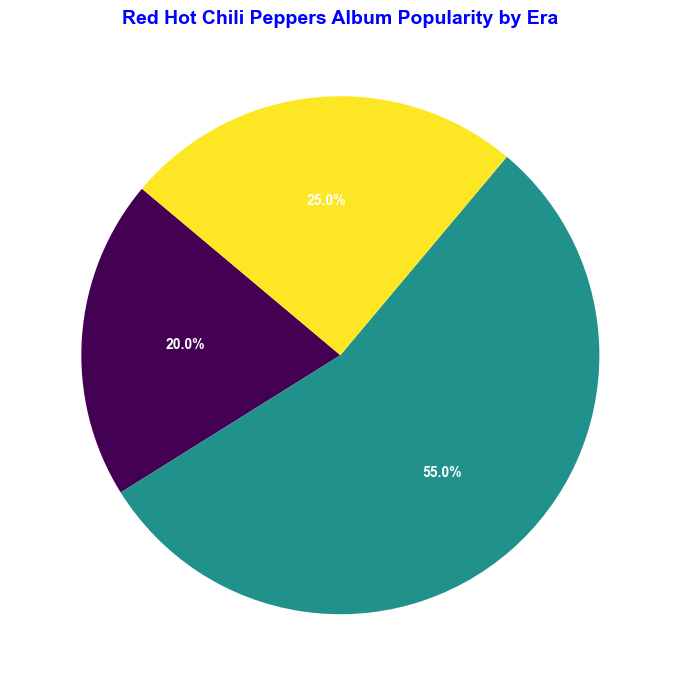What's the most popular album era for Red Hot Chili Peppers based on the pie chart? The '1990s' era has the largest segment in the pie chart.
Answer: 1990s How does the popularity of albums released in the 2000s compare to those in the 1980s? The 2000s have a larger segment in the pie chart (25%) compared to the 1980s (20%).
Answer: 2000s What percentage of the overall popularity is contributed by albums from the '1990s era'? The pie chart indicates that the 1990s sum up to 55% (20% for Blood Sugar Sex Magik, 10% for One Hot Minute, 25% for Californication).
Answer: 55% How much more popular is the '1990s' era compared to the '1980s' era? The '1990s' era contributes 55%, while the '1980s' era contributes 20%, so the difference is 55% - 20% = 35%.
Answer: 35% What is the sum of the popularity percentages of albums from the 1980s and 2000s? The 1980s contribute 20%, and the 2000s contribute 25%, so their sum is 20% + 25% = 45%.
Answer: 45% Which album from the 1980s is the most popular, and what is its percentage? From the 1980s, "Mother's Milk (1989)" has the highest percentage at 7%.
Answer: Mother's Milk (1989), 7% Arrange the eras by their overall album popularity in descending order. The percentages indicate that the order from most to least popular is: 1990s (55%), 2000s (25%), 1980s (20%).
Answer: 1990s, 2000s, 1980s Is the popularity of ‘Blood Sugar Sex Magik (1991)’ greater than the total popularity of all 1980s' albums? ‘Blood Sugar Sex Magik (1991)’ has 20% while the total of all 1980s' albums is (5% + 3% + 5% + 7%) = 20%. Both are equal.
Answer: Equal What era has the smallest pie segment, and what is the percentage? The 1980s era has the smallest overall segment at 20%.
Answer: 1980s, 20% Which album is the least popular among all shown in the pie chart? "Freaky Styley (1985)" from the 1980s has the smallest individual percentage at 3%.
Answer: Freaky Styley (1985) 